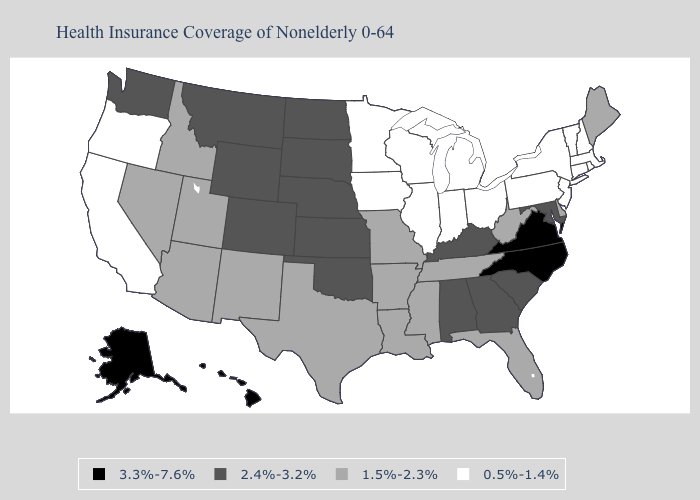What is the value of Mississippi?
Give a very brief answer. 1.5%-2.3%. Name the states that have a value in the range 1.5%-2.3%?
Give a very brief answer. Arizona, Arkansas, Delaware, Florida, Idaho, Louisiana, Maine, Mississippi, Missouri, Nevada, New Mexico, Tennessee, Texas, Utah, West Virginia. Does Oregon have the highest value in the West?
Answer briefly. No. Does Kansas have the highest value in the USA?
Concise answer only. No. Among the states that border Montana , which have the lowest value?
Answer briefly. Idaho. Does Nevada have the highest value in the USA?
Quick response, please. No. Among the states that border Oklahoma , which have the highest value?
Concise answer only. Colorado, Kansas. Among the states that border Iowa , which have the lowest value?
Give a very brief answer. Illinois, Minnesota, Wisconsin. Name the states that have a value in the range 2.4%-3.2%?
Quick response, please. Alabama, Colorado, Georgia, Kansas, Kentucky, Maryland, Montana, Nebraska, North Dakota, Oklahoma, South Carolina, South Dakota, Washington, Wyoming. What is the value of Kansas?
Be succinct. 2.4%-3.2%. What is the value of Georgia?
Write a very short answer. 2.4%-3.2%. Is the legend a continuous bar?
Give a very brief answer. No. Among the states that border New Mexico , which have the lowest value?
Concise answer only. Arizona, Texas, Utah. What is the value of Texas?
Be succinct. 1.5%-2.3%. What is the value of Tennessee?
Give a very brief answer. 1.5%-2.3%. 